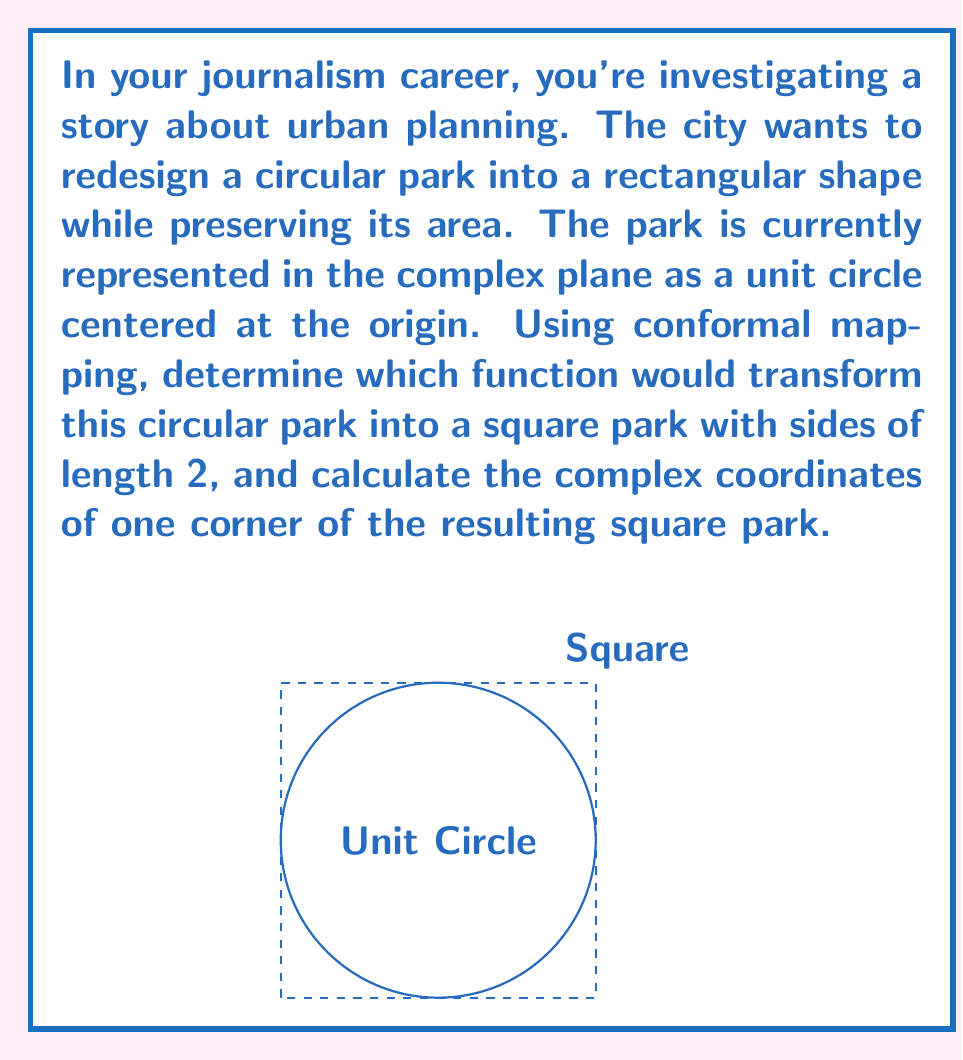Could you help me with this problem? To solve this problem, we'll use the following steps:

1) The conformal mapping that transforms a unit circle to a square is the Schwarz-Christoffel mapping. Specifically, we'll use the function:

   $$f(z) = \int_0^z \frac{dt}{\sqrt{1-t^4}}$$

2) This integral doesn't have a simple closed form, but it can be expressed in terms of elliptic functions. For our purposes, we need to know that this function maps the unit circle to a square.

3) To determine the size and position of the square, we need to evaluate the function at key points. The points $z = \pm 1, \pm i$ on the unit circle map to the corners of the square.

4) The constant of integration in the mapping function can be chosen so that $f(1) = 1 + i$. This places one corner of the square at $(1,1)$ in the complex plane.

5) Given that the original park has an area of $\pi$ (the area of a unit circle), and the new square park should have the same area, its side length should be $\sqrt{\pi}$.

6) To adjust the size of the square, we need to scale our mapping function. The scaling factor would be $\frac{2}{\sqrt{\pi}}$ to achieve a square with side length 2.

7) Therefore, the complete mapping function is:

   $$F(z) = \frac{2}{\sqrt{\pi}} \int_0^z \frac{dt}{\sqrt{1-t^4}}$$

8) One corner of the resulting square park will be at:

   $$F(1) = \frac{2}{\sqrt{\pi}}(1+i)$$

This point represents the complex coordinates of one corner of the square park.
Answer: $F(z) = \frac{2}{\sqrt{\pi}} \int_0^z \frac{dt}{\sqrt{1-t^4}}$; Corner at $\frac{2}{\sqrt{\pi}}(1+i)$ 